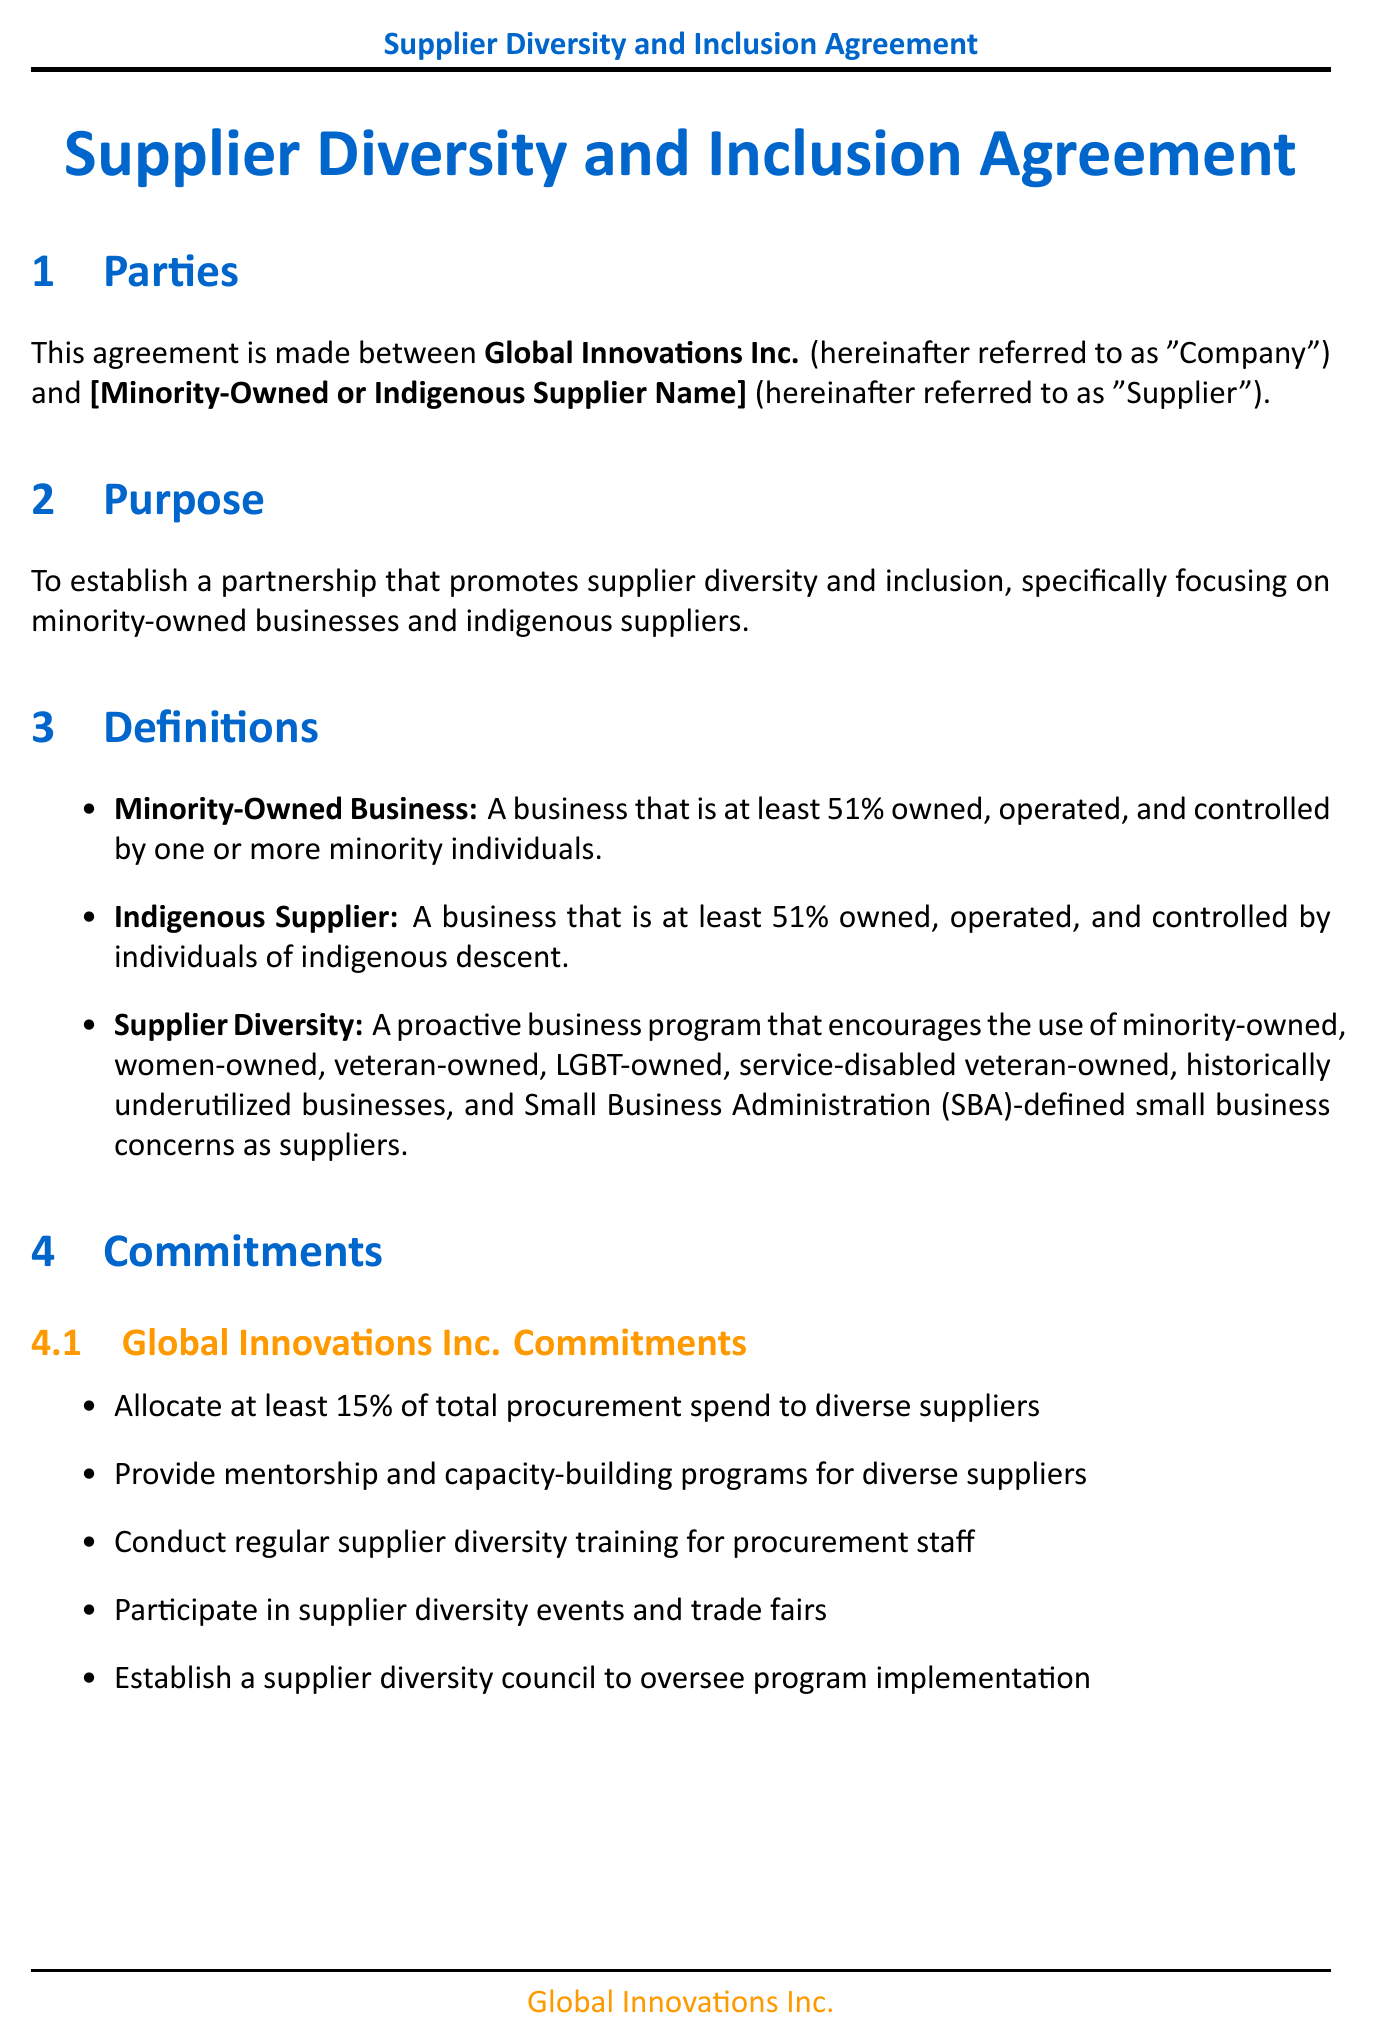what is the title of the contract? The title of the contract is stated at the beginning of the document.
Answer: Supplier Diversity and Inclusion Agreement who is the Chief Procurement Officer of Global Innovations Inc.? The document includes a signature block with the name and title of the authorized representative of Global Innovations Inc.
Answer: Sarah Chen what percentage of total procurement spend is allocated to diverse suppliers? The commitments section specifies the allocation heeding the supplier diversity goals.
Answer: 15% how long is the initial term of the agreement? The term and termination section outlines the duration of the initial term.
Answer: 3 years what is the process for dispute resolution? The dispute resolution section describes the steps to be taken in case of disputes.
Answer: Mediation followed by binding arbitration how many diverse suppliers are to be onboarded annually? Performance metrics indicate a target related to onboarding diverse suppliers.
Answer: Number of new diverse suppliers onboarded annually what is one economic development initiative mentioned in the document? The economic development initiatives section lists multiple initiatives aimed at community support.
Answer: Joint investment in local community projects what is required for termination without cause? The termination notice outlines what is needed for a party to terminate the agreement.
Answer: 90 days written notice required what type of businesses are emphasized for supplier diversity? The definitions section describes the types of businesses being targeted under the diversity initiative.
Answer: minority-owned and indigenous suppliers 